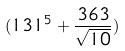Convert formula to latex. <formula><loc_0><loc_0><loc_500><loc_500>( 1 3 1 ^ { 5 } + \frac { 3 6 3 } { \sqrt { 1 0 } } )</formula> 